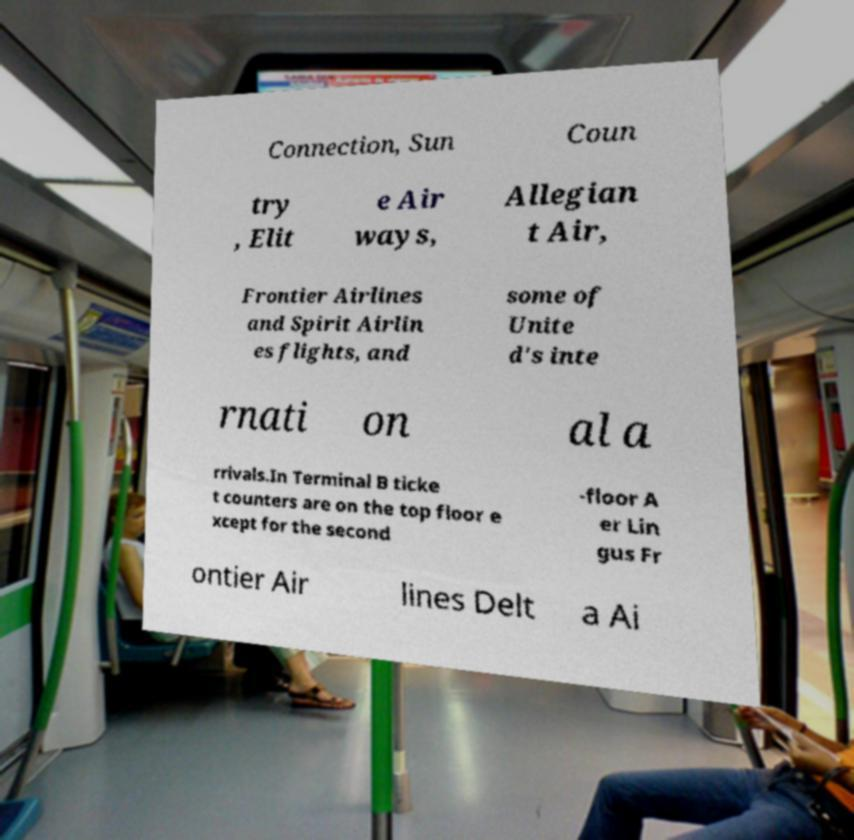Can you read and provide the text displayed in the image?This photo seems to have some interesting text. Can you extract and type it out for me? Connection, Sun Coun try , Elit e Air ways, Allegian t Air, Frontier Airlines and Spirit Airlin es flights, and some of Unite d's inte rnati on al a rrivals.In Terminal B ticke t counters are on the top floor e xcept for the second -floor A er Lin gus Fr ontier Air lines Delt a Ai 